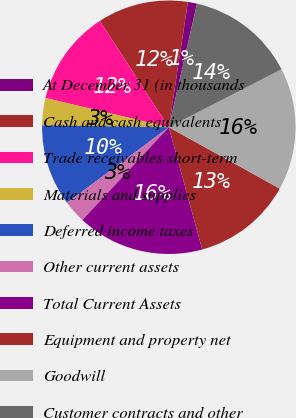<chart> <loc_0><loc_0><loc_500><loc_500><pie_chart><fcel>At December 31 (in thousands<fcel>Cash and cash equivalents<fcel>Trade receivables short-term<fcel>Materials and supplies<fcel>Deferred income taxes<fcel>Other current assets<fcel>Total Current Assets<fcel>Equipment and property net<fcel>Goodwill<fcel>Customer contracts and other<nl><fcel>1.16%<fcel>11.56%<fcel>12.14%<fcel>3.47%<fcel>10.4%<fcel>2.9%<fcel>16.18%<fcel>12.71%<fcel>15.6%<fcel>13.87%<nl></chart> 